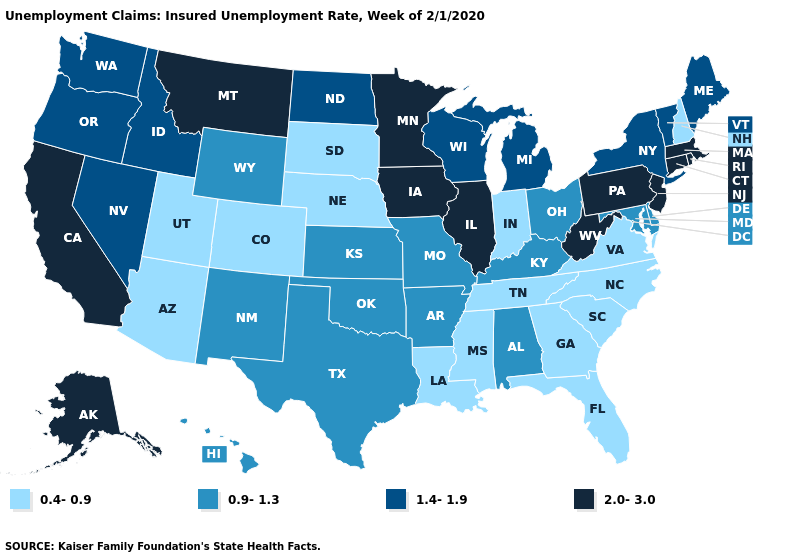What is the lowest value in the MidWest?
Be succinct. 0.4-0.9. Which states have the lowest value in the USA?
Quick response, please. Arizona, Colorado, Florida, Georgia, Indiana, Louisiana, Mississippi, Nebraska, New Hampshire, North Carolina, South Carolina, South Dakota, Tennessee, Utah, Virginia. What is the value of Utah?
Be succinct. 0.4-0.9. Does Pennsylvania have the lowest value in the USA?
Keep it brief. No. What is the lowest value in the USA?
Answer briefly. 0.4-0.9. What is the value of Iowa?
Concise answer only. 2.0-3.0. What is the value of Vermont?
Concise answer only. 1.4-1.9. Does Virginia have the lowest value in the USA?
Quick response, please. Yes. Name the states that have a value in the range 0.9-1.3?
Write a very short answer. Alabama, Arkansas, Delaware, Hawaii, Kansas, Kentucky, Maryland, Missouri, New Mexico, Ohio, Oklahoma, Texas, Wyoming. Does New Jersey have the highest value in the Northeast?
Be succinct. Yes. Does the first symbol in the legend represent the smallest category?
Write a very short answer. Yes. How many symbols are there in the legend?
Keep it brief. 4. Does Texas have the lowest value in the USA?
Give a very brief answer. No. Name the states that have a value in the range 2.0-3.0?
Be succinct. Alaska, California, Connecticut, Illinois, Iowa, Massachusetts, Minnesota, Montana, New Jersey, Pennsylvania, Rhode Island, West Virginia. What is the value of Massachusetts?
Quick response, please. 2.0-3.0. 